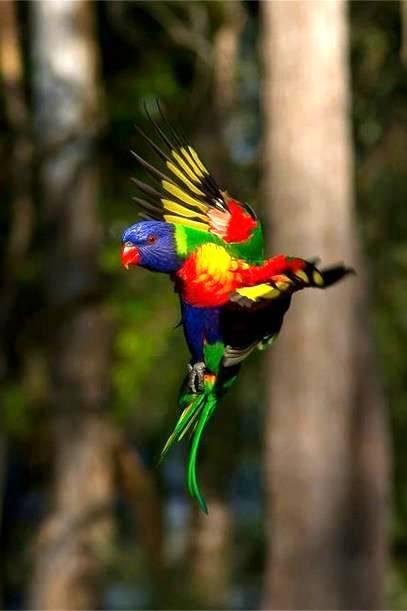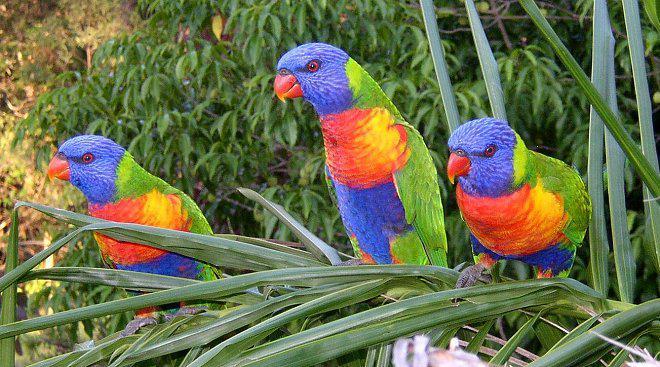The first image is the image on the left, the second image is the image on the right. Examine the images to the left and right. Is the description "At least two parrots are perched in branches containing bright red flower-like growths." accurate? Answer yes or no. No. The first image is the image on the left, the second image is the image on the right. Assess this claim about the two images: "At least one of the images shows three colourful parrots perched on a branch.". Correct or not? Answer yes or no. Yes. 